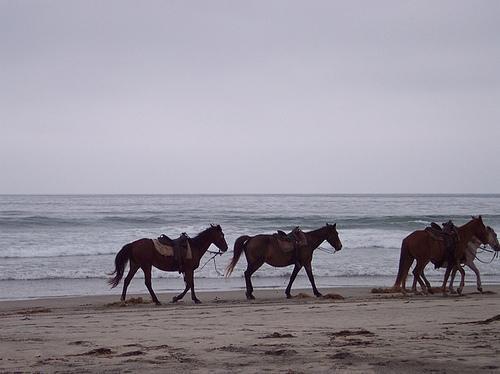How many horses are in the picture?
Give a very brief answer. 4. How many horses are in the photo?
Give a very brief answer. 4. How many horses are in this picture?
Give a very brief answer. 4. How many horses are in the picture?
Give a very brief answer. 3. 